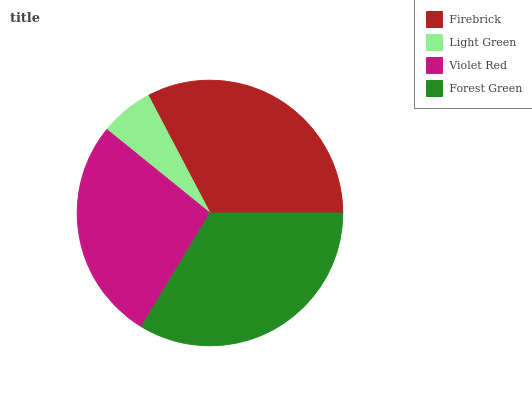Is Light Green the minimum?
Answer yes or no. Yes. Is Forest Green the maximum?
Answer yes or no. Yes. Is Violet Red the minimum?
Answer yes or no. No. Is Violet Red the maximum?
Answer yes or no. No. Is Violet Red greater than Light Green?
Answer yes or no. Yes. Is Light Green less than Violet Red?
Answer yes or no. Yes. Is Light Green greater than Violet Red?
Answer yes or no. No. Is Violet Red less than Light Green?
Answer yes or no. No. Is Firebrick the high median?
Answer yes or no. Yes. Is Violet Red the low median?
Answer yes or no. Yes. Is Light Green the high median?
Answer yes or no. No. Is Light Green the low median?
Answer yes or no. No. 